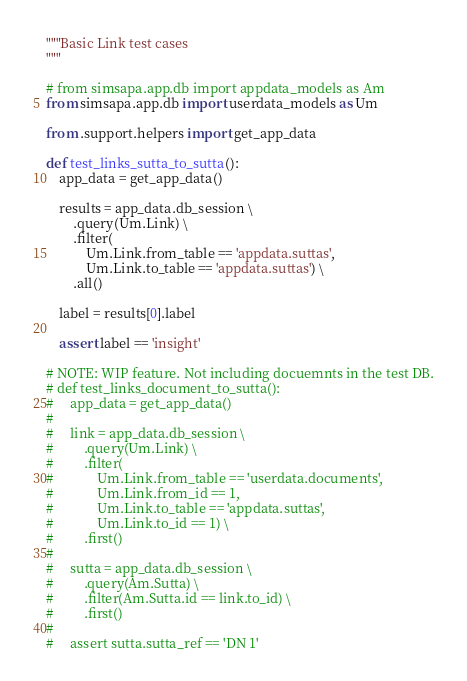<code> <loc_0><loc_0><loc_500><loc_500><_Python_>"""Basic Link test cases
"""

# from simsapa.app.db import appdata_models as Am
from simsapa.app.db import userdata_models as Um

from .support.helpers import get_app_data

def test_links_sutta_to_sutta():
    app_data = get_app_data()

    results = app_data.db_session \
        .query(Um.Link) \
        .filter(
            Um.Link.from_table == 'appdata.suttas',
            Um.Link.to_table == 'appdata.suttas') \
        .all()

    label = results[0].label

    assert label == 'insight'

# NOTE: WIP feature. Not including docuemnts in the test DB.
# def test_links_document_to_sutta():
#     app_data = get_app_data()
#
#     link = app_data.db_session \
#         .query(Um.Link) \
#         .filter(
#             Um.Link.from_table == 'userdata.documents',
#             Um.Link.from_id == 1,
#             Um.Link.to_table == 'appdata.suttas',
#             Um.Link.to_id == 1) \
#         .first()
#
#     sutta = app_data.db_session \
#         .query(Am.Sutta) \
#         .filter(Am.Sutta.id == link.to_id) \
#         .first()
#
#     assert sutta.sutta_ref == 'DN 1'
</code> 